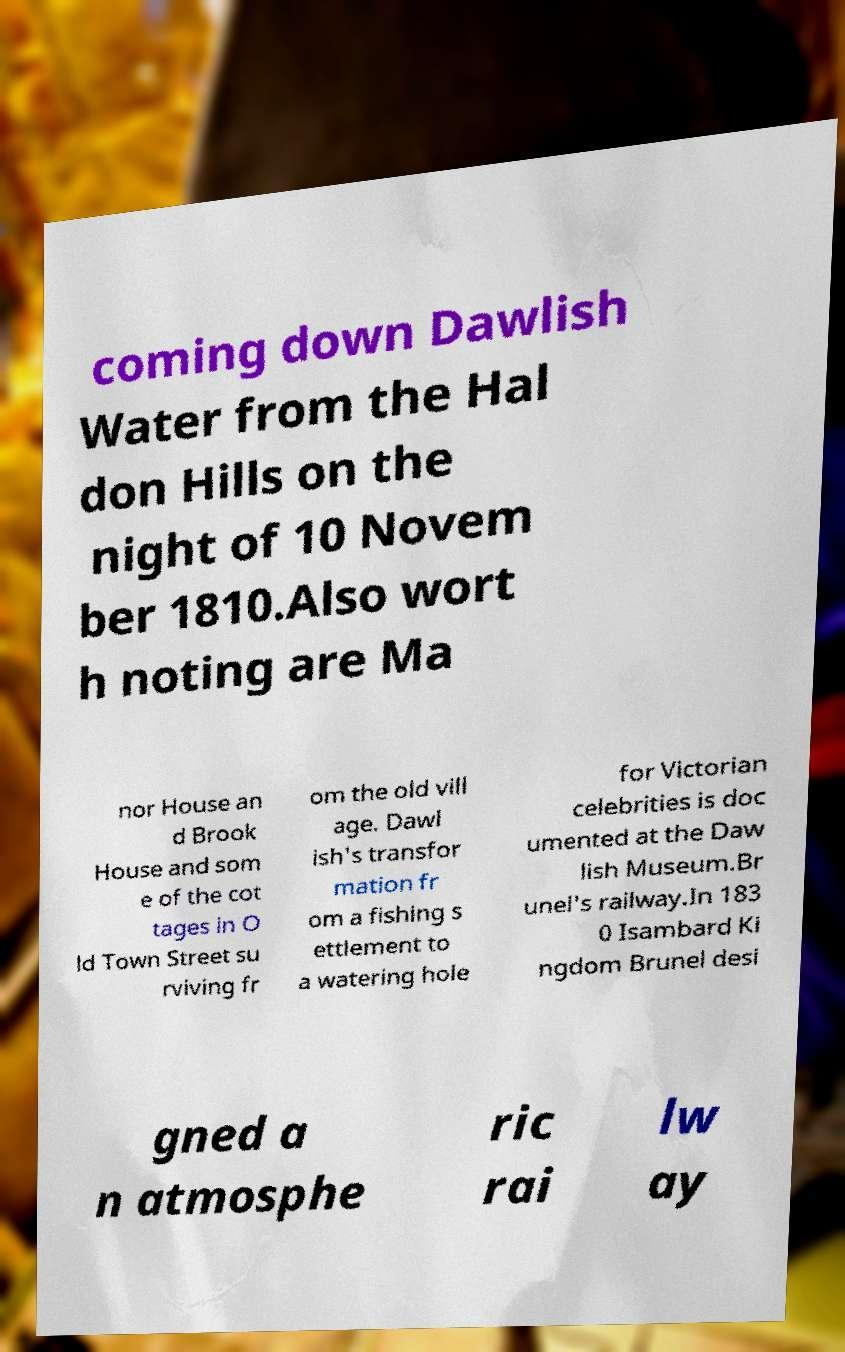Could you extract and type out the text from this image? coming down Dawlish Water from the Hal don Hills on the night of 10 Novem ber 1810.Also wort h noting are Ma nor House an d Brook House and som e of the cot tages in O ld Town Street su rviving fr om the old vill age. Dawl ish's transfor mation fr om a fishing s ettlement to a watering hole for Victorian celebrities is doc umented at the Daw lish Museum.Br unel's railway.In 183 0 Isambard Ki ngdom Brunel desi gned a n atmosphe ric rai lw ay 